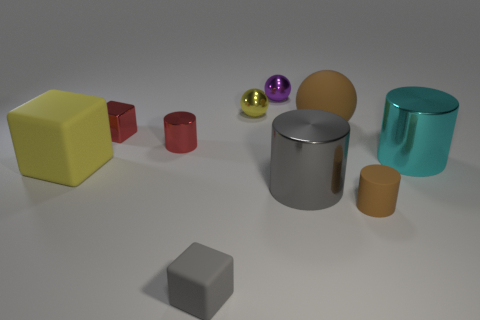Do the yellow ball and the brown cylinder have the same size?
Keep it short and to the point. Yes. What number of things are rubber cylinders or small cylinders on the right side of the small yellow ball?
Ensure brevity in your answer.  1. There is a red block that is the same size as the gray matte cube; what is it made of?
Your response must be concise. Metal. There is a cylinder that is both to the right of the tiny purple metallic ball and behind the yellow rubber block; what is its material?
Provide a succinct answer. Metal. There is a big rubber thing behind the big yellow rubber thing; are there any tiny purple metal balls right of it?
Ensure brevity in your answer.  No. How big is the cylinder that is both left of the tiny brown matte thing and behind the gray cylinder?
Make the answer very short. Small. How many cyan objects are either small metal spheres or large metallic things?
Your response must be concise. 1. What is the shape of the yellow shiny object that is the same size as the red cube?
Your response must be concise. Sphere. What number of other things are the same color as the rubber ball?
Your answer should be very brief. 1. There is a yellow object that is in front of the big matte object to the right of the purple thing; what size is it?
Make the answer very short. Large. 